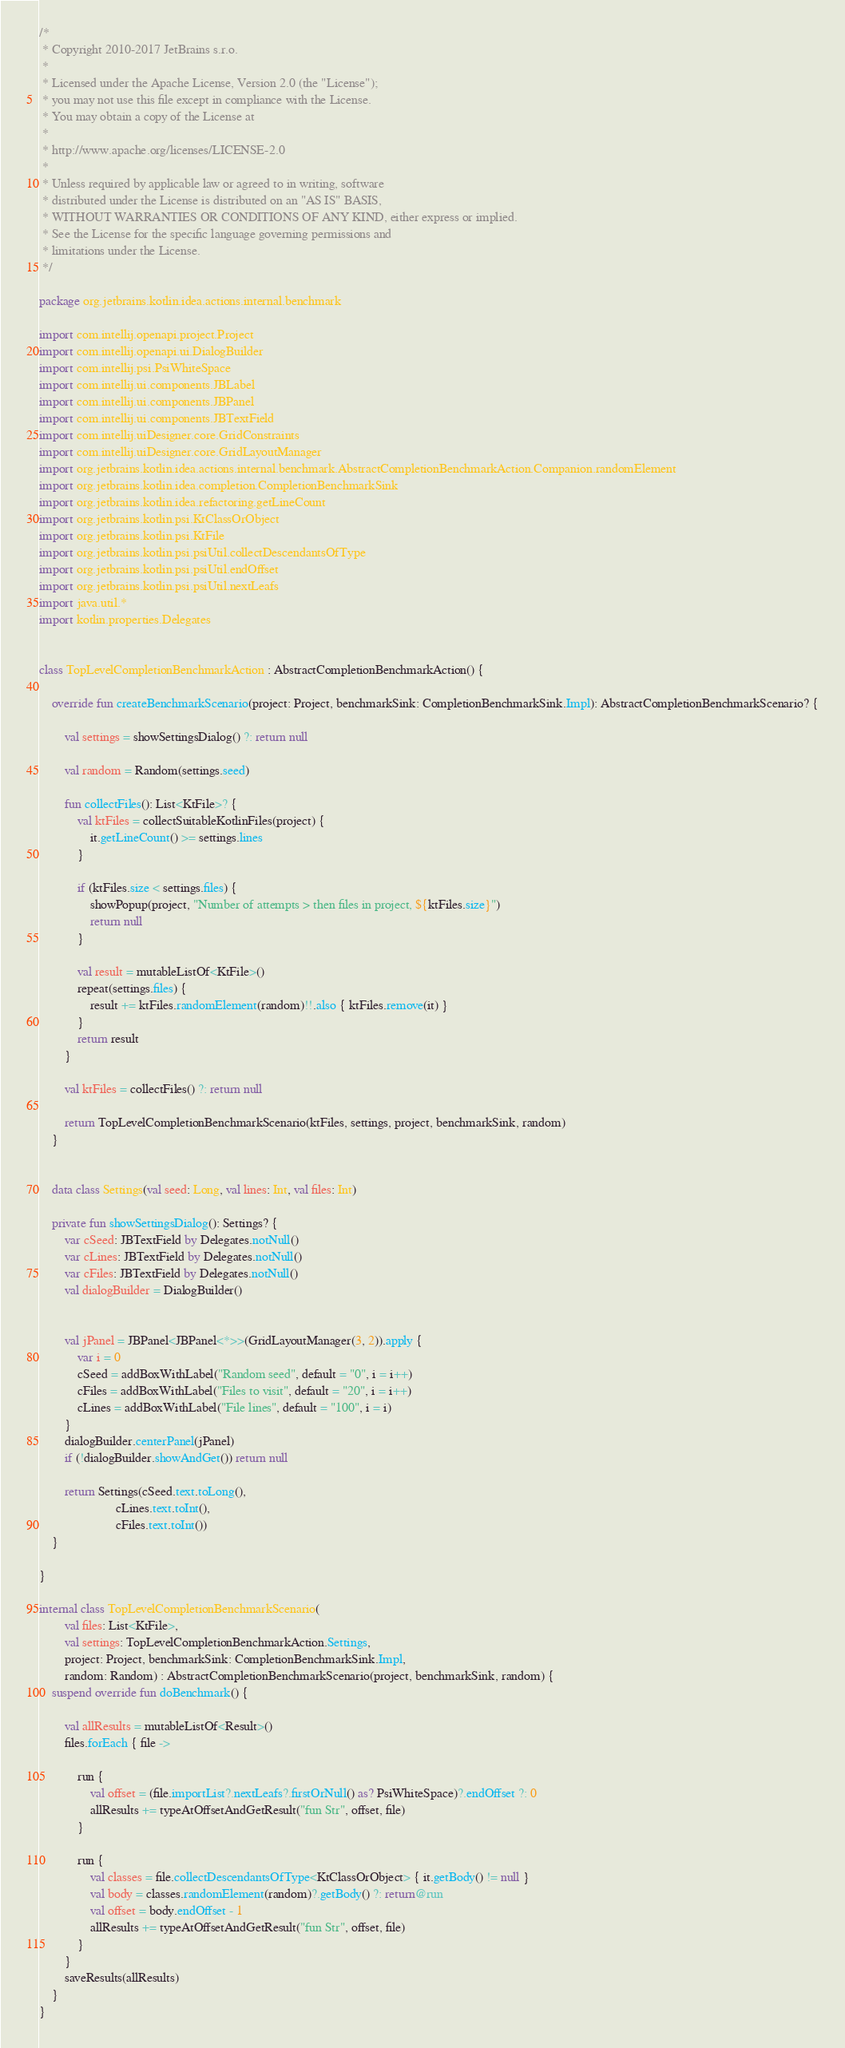<code> <loc_0><loc_0><loc_500><loc_500><_Kotlin_>/*
 * Copyright 2010-2017 JetBrains s.r.o.
 *
 * Licensed under the Apache License, Version 2.0 (the "License");
 * you may not use this file except in compliance with the License.
 * You may obtain a copy of the License at
 *
 * http://www.apache.org/licenses/LICENSE-2.0
 *
 * Unless required by applicable law or agreed to in writing, software
 * distributed under the License is distributed on an "AS IS" BASIS,
 * WITHOUT WARRANTIES OR CONDITIONS OF ANY KIND, either express or implied.
 * See the License for the specific language governing permissions and
 * limitations under the License.
 */

package org.jetbrains.kotlin.idea.actions.internal.benchmark

import com.intellij.openapi.project.Project
import com.intellij.openapi.ui.DialogBuilder
import com.intellij.psi.PsiWhiteSpace
import com.intellij.ui.components.JBLabel
import com.intellij.ui.components.JBPanel
import com.intellij.ui.components.JBTextField
import com.intellij.uiDesigner.core.GridConstraints
import com.intellij.uiDesigner.core.GridLayoutManager
import org.jetbrains.kotlin.idea.actions.internal.benchmark.AbstractCompletionBenchmarkAction.Companion.randomElement
import org.jetbrains.kotlin.idea.completion.CompletionBenchmarkSink
import org.jetbrains.kotlin.idea.refactoring.getLineCount
import org.jetbrains.kotlin.psi.KtClassOrObject
import org.jetbrains.kotlin.psi.KtFile
import org.jetbrains.kotlin.psi.psiUtil.collectDescendantsOfType
import org.jetbrains.kotlin.psi.psiUtil.endOffset
import org.jetbrains.kotlin.psi.psiUtil.nextLeafs
import java.util.*
import kotlin.properties.Delegates


class TopLevelCompletionBenchmarkAction : AbstractCompletionBenchmarkAction() {

    override fun createBenchmarkScenario(project: Project, benchmarkSink: CompletionBenchmarkSink.Impl): AbstractCompletionBenchmarkScenario? {

        val settings = showSettingsDialog() ?: return null

        val random = Random(settings.seed)

        fun collectFiles(): List<KtFile>? {
            val ktFiles = collectSuitableKotlinFiles(project) {
                it.getLineCount() >= settings.lines
            }

            if (ktFiles.size < settings.files) {
                showPopup(project, "Number of attempts > then files in project, ${ktFiles.size}")
                return null
            }

            val result = mutableListOf<KtFile>()
            repeat(settings.files) {
                result += ktFiles.randomElement(random)!!.also { ktFiles.remove(it) }
            }
            return result
        }

        val ktFiles = collectFiles() ?: return null

        return TopLevelCompletionBenchmarkScenario(ktFiles, settings, project, benchmarkSink, random)
    }


    data class Settings(val seed: Long, val lines: Int, val files: Int)

    private fun showSettingsDialog(): Settings? {
        var cSeed: JBTextField by Delegates.notNull()
        var cLines: JBTextField by Delegates.notNull()
        var cFiles: JBTextField by Delegates.notNull()
        val dialogBuilder = DialogBuilder()


        val jPanel = JBPanel<JBPanel<*>>(GridLayoutManager(3, 2)).apply {
            var i = 0
            cSeed = addBoxWithLabel("Random seed", default = "0", i = i++)
            cFiles = addBoxWithLabel("Files to visit", default = "20", i = i++)
            cLines = addBoxWithLabel("File lines", default = "100", i = i)
        }
        dialogBuilder.centerPanel(jPanel)
        if (!dialogBuilder.showAndGet()) return null

        return Settings(cSeed.text.toLong(),
                        cLines.text.toInt(),
                        cFiles.text.toInt())
    }

}

internal class TopLevelCompletionBenchmarkScenario(
        val files: List<KtFile>,
        val settings: TopLevelCompletionBenchmarkAction.Settings,
        project: Project, benchmarkSink: CompletionBenchmarkSink.Impl,
        random: Random) : AbstractCompletionBenchmarkScenario(project, benchmarkSink, random) {
    suspend override fun doBenchmark() {

        val allResults = mutableListOf<Result>()
        files.forEach { file ->

            run {
                val offset = (file.importList?.nextLeafs?.firstOrNull() as? PsiWhiteSpace)?.endOffset ?: 0
                allResults += typeAtOffsetAndGetResult("fun Str", offset, file)
            }

            run {
                val classes = file.collectDescendantsOfType<KtClassOrObject> { it.getBody() != null }
                val body = classes.randomElement(random)?.getBody() ?: return@run
                val offset = body.endOffset - 1
                allResults += typeAtOffsetAndGetResult("fun Str", offset, file)
            }
        }
        saveResults(allResults)
    }
}</code> 